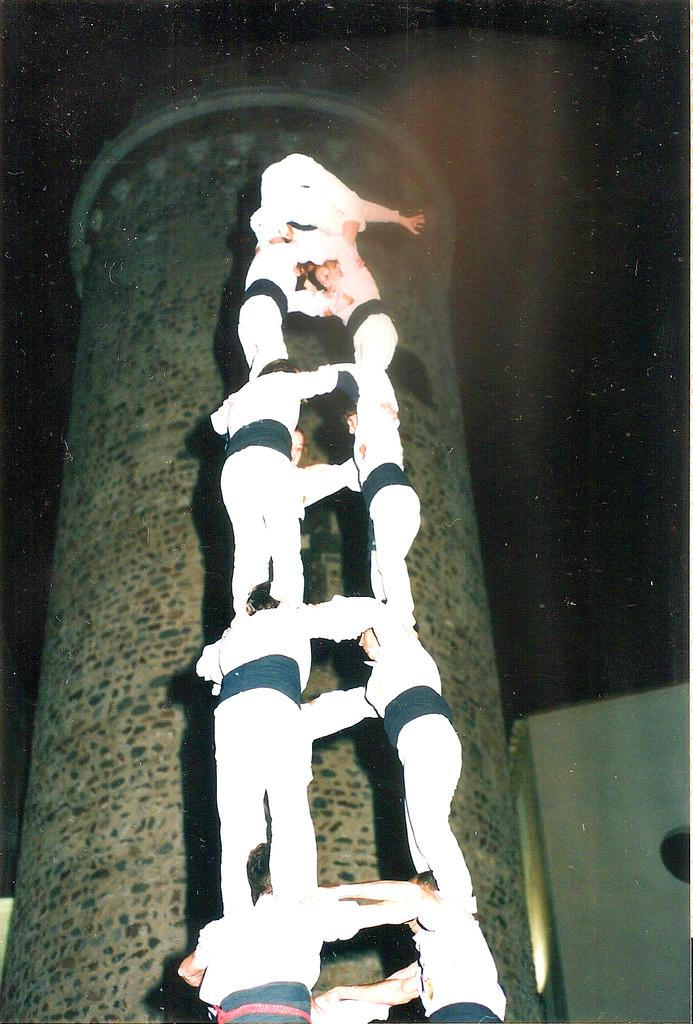What is the main subject of the image? The main subject of the image is a group of people. How are the people positioned in the image? The people are standing one above the other. What can be seen in the background of the image? There is a wall in the background of the image. What type of trail can be seen in the image? There is no trail present in the image. 